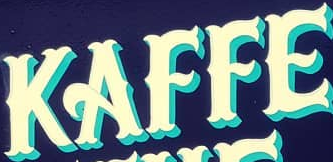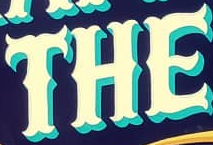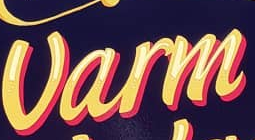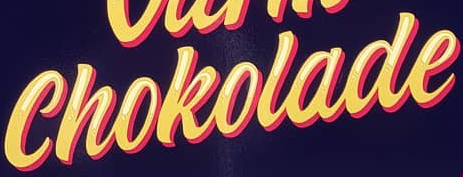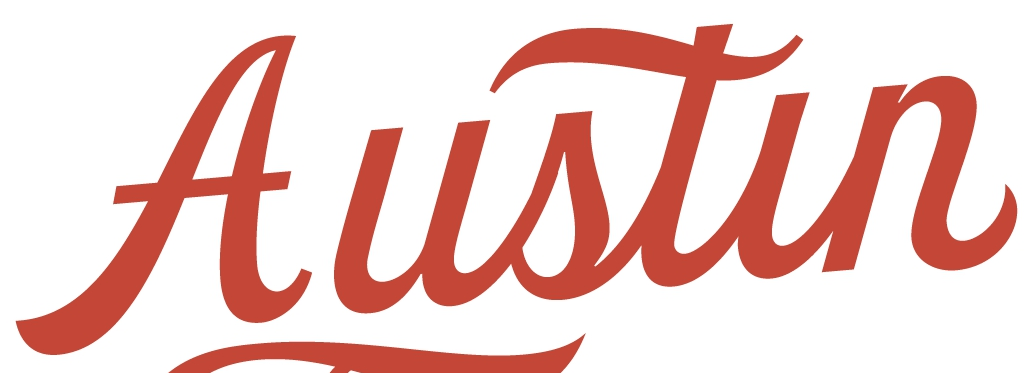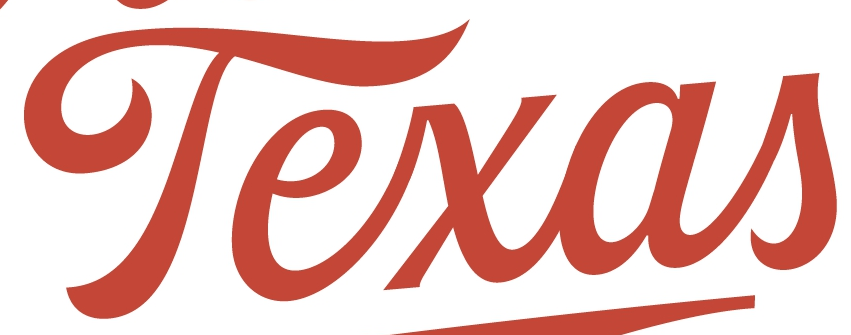What words can you see in these images in sequence, separated by a semicolon? KAFFE; THE; Varm; Chokolade; Austin; Texas 